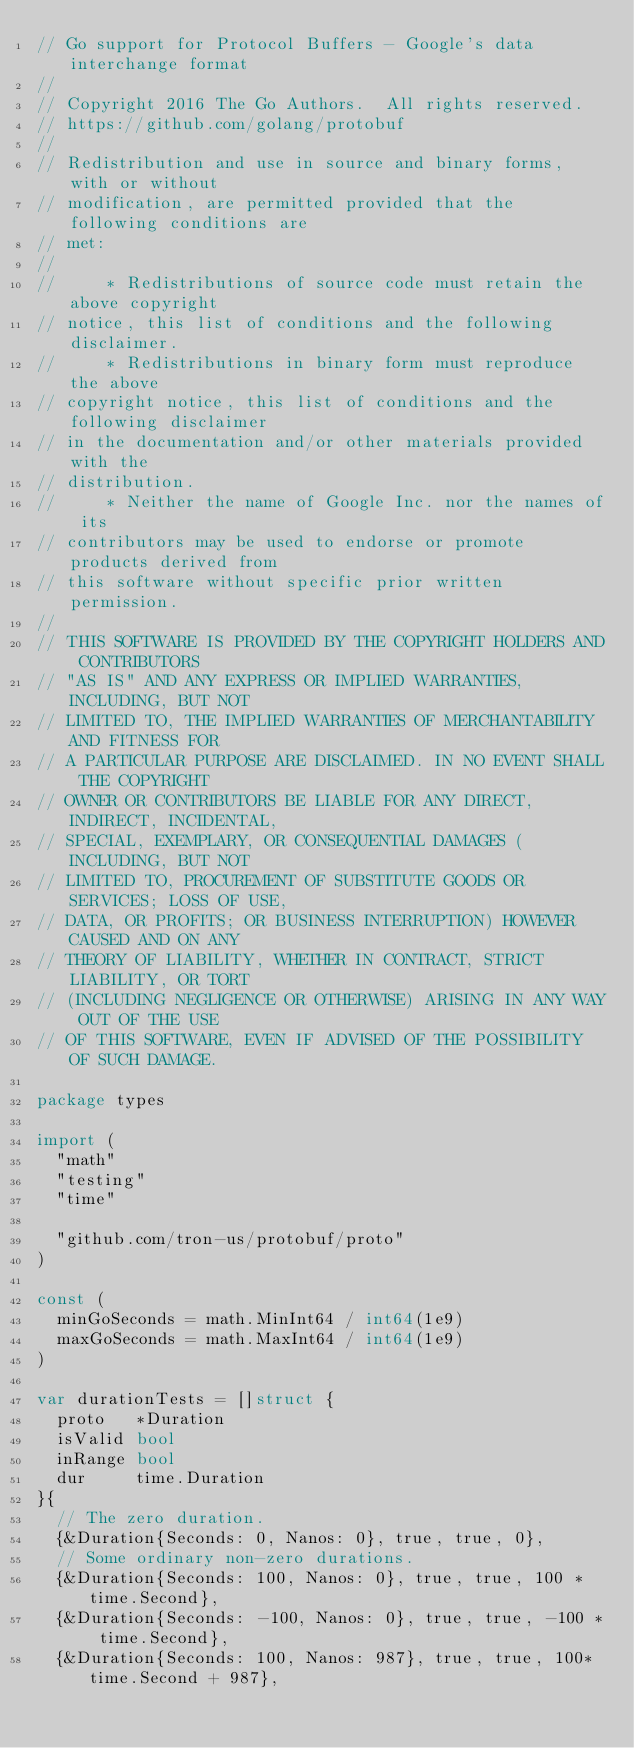<code> <loc_0><loc_0><loc_500><loc_500><_Go_>// Go support for Protocol Buffers - Google's data interchange format
//
// Copyright 2016 The Go Authors.  All rights reserved.
// https://github.com/golang/protobuf
//
// Redistribution and use in source and binary forms, with or without
// modification, are permitted provided that the following conditions are
// met:
//
//     * Redistributions of source code must retain the above copyright
// notice, this list of conditions and the following disclaimer.
//     * Redistributions in binary form must reproduce the above
// copyright notice, this list of conditions and the following disclaimer
// in the documentation and/or other materials provided with the
// distribution.
//     * Neither the name of Google Inc. nor the names of its
// contributors may be used to endorse or promote products derived from
// this software without specific prior written permission.
//
// THIS SOFTWARE IS PROVIDED BY THE COPYRIGHT HOLDERS AND CONTRIBUTORS
// "AS IS" AND ANY EXPRESS OR IMPLIED WARRANTIES, INCLUDING, BUT NOT
// LIMITED TO, THE IMPLIED WARRANTIES OF MERCHANTABILITY AND FITNESS FOR
// A PARTICULAR PURPOSE ARE DISCLAIMED. IN NO EVENT SHALL THE COPYRIGHT
// OWNER OR CONTRIBUTORS BE LIABLE FOR ANY DIRECT, INDIRECT, INCIDENTAL,
// SPECIAL, EXEMPLARY, OR CONSEQUENTIAL DAMAGES (INCLUDING, BUT NOT
// LIMITED TO, PROCUREMENT OF SUBSTITUTE GOODS OR SERVICES; LOSS OF USE,
// DATA, OR PROFITS; OR BUSINESS INTERRUPTION) HOWEVER CAUSED AND ON ANY
// THEORY OF LIABILITY, WHETHER IN CONTRACT, STRICT LIABILITY, OR TORT
// (INCLUDING NEGLIGENCE OR OTHERWISE) ARISING IN ANY WAY OUT OF THE USE
// OF THIS SOFTWARE, EVEN IF ADVISED OF THE POSSIBILITY OF SUCH DAMAGE.

package types

import (
	"math"
	"testing"
	"time"

	"github.com/tron-us/protobuf/proto"
)

const (
	minGoSeconds = math.MinInt64 / int64(1e9)
	maxGoSeconds = math.MaxInt64 / int64(1e9)
)

var durationTests = []struct {
	proto   *Duration
	isValid bool
	inRange bool
	dur     time.Duration
}{
	// The zero duration.
	{&Duration{Seconds: 0, Nanos: 0}, true, true, 0},
	// Some ordinary non-zero durations.
	{&Duration{Seconds: 100, Nanos: 0}, true, true, 100 * time.Second},
	{&Duration{Seconds: -100, Nanos: 0}, true, true, -100 * time.Second},
	{&Duration{Seconds: 100, Nanos: 987}, true, true, 100*time.Second + 987},</code> 